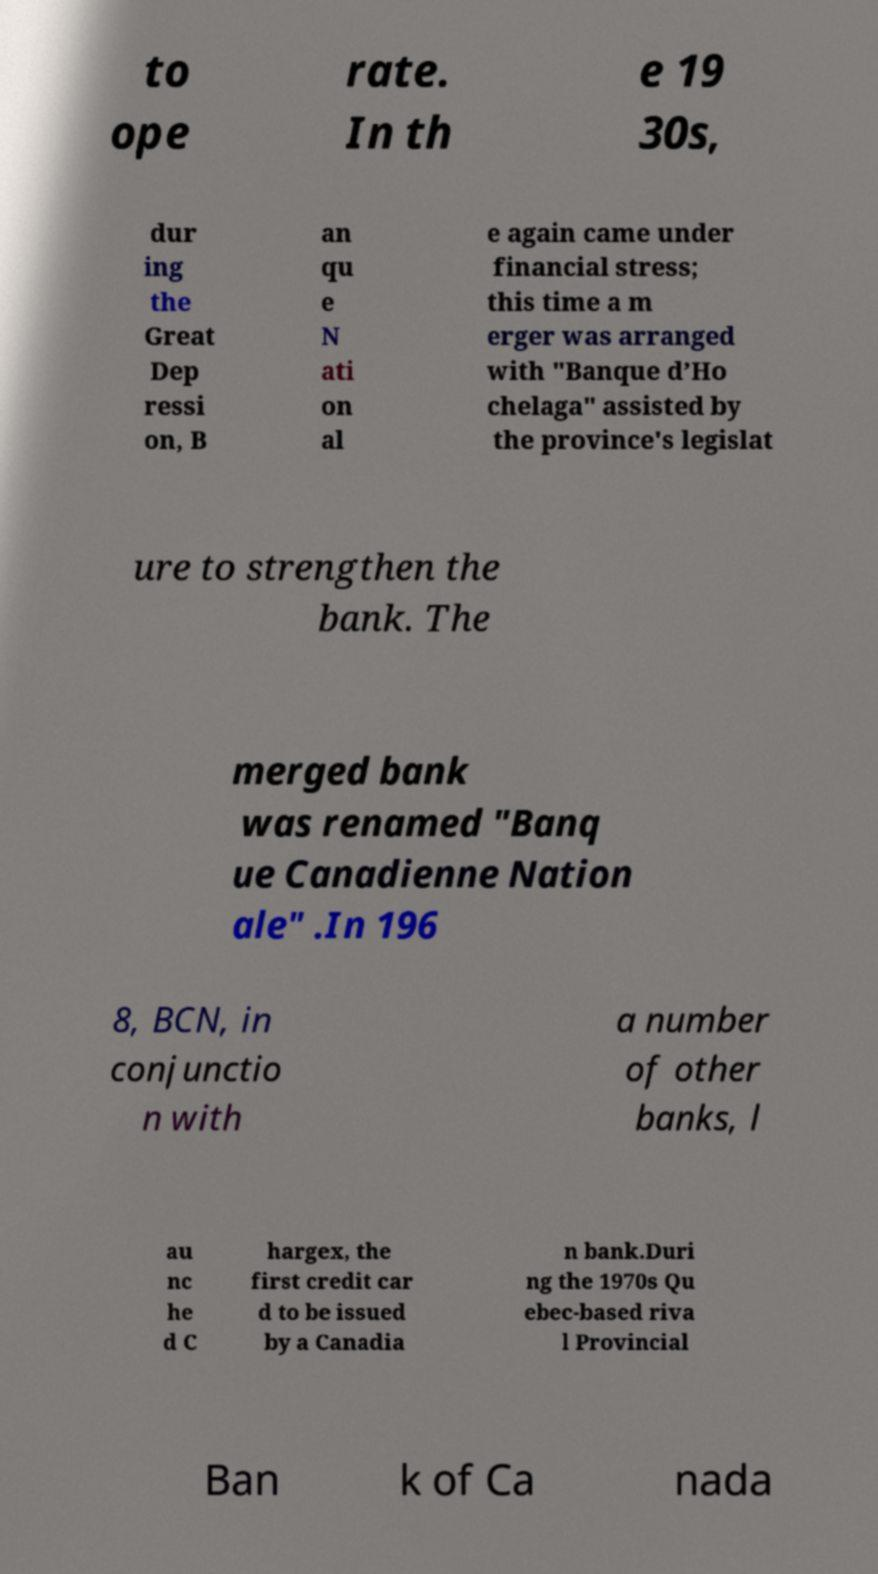Please read and relay the text visible in this image. What does it say? to ope rate. In th e 19 30s, dur ing the Great Dep ressi on, B an qu e N ati on al e again came under financial stress; this time a m erger was arranged with "Banque d’Ho chelaga" assisted by the province's legislat ure to strengthen the bank. The merged bank was renamed "Banq ue Canadienne Nation ale" .In 196 8, BCN, in conjunctio n with a number of other banks, l au nc he d C hargex, the first credit car d to be issued by a Canadia n bank.Duri ng the 1970s Qu ebec-based riva l Provincial Ban k of Ca nada 